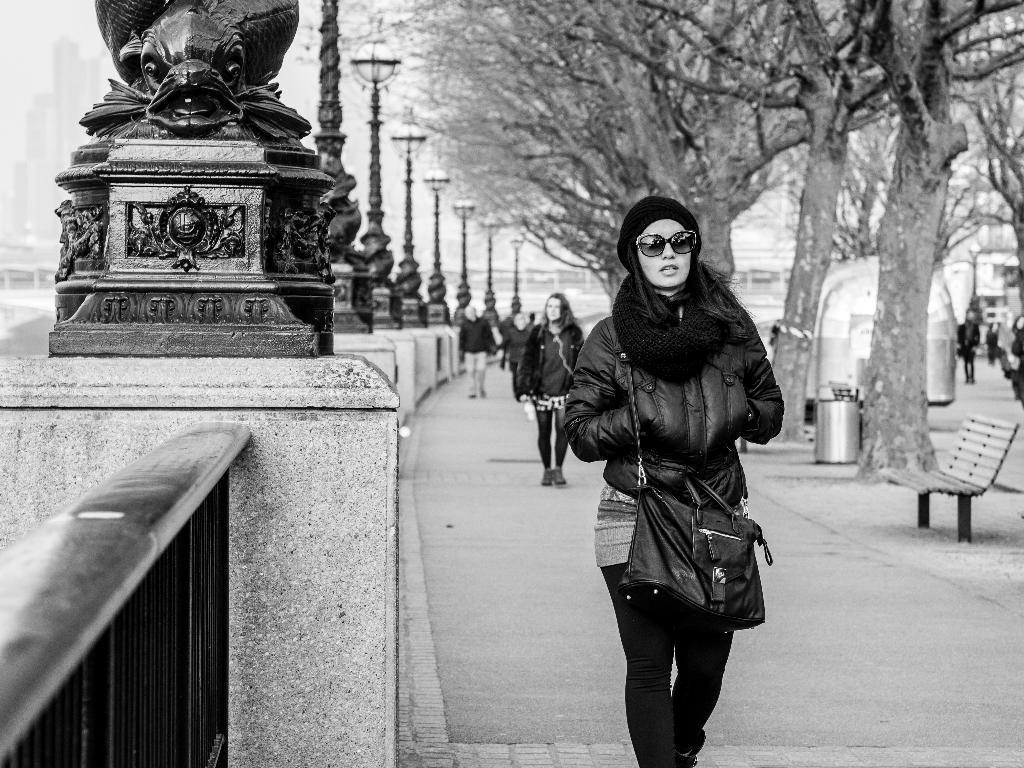Could you give a brief overview of what you see in this image? In front of the image there are a few people walking on the pavement, on the left side of the pavement there are lamp posts on the concrete structures, beside that there are metal rod fences. On the right side of the image there are trees, trash cans, benches. In the background of the image there are a few other people walking on the roads and there are buildings. 